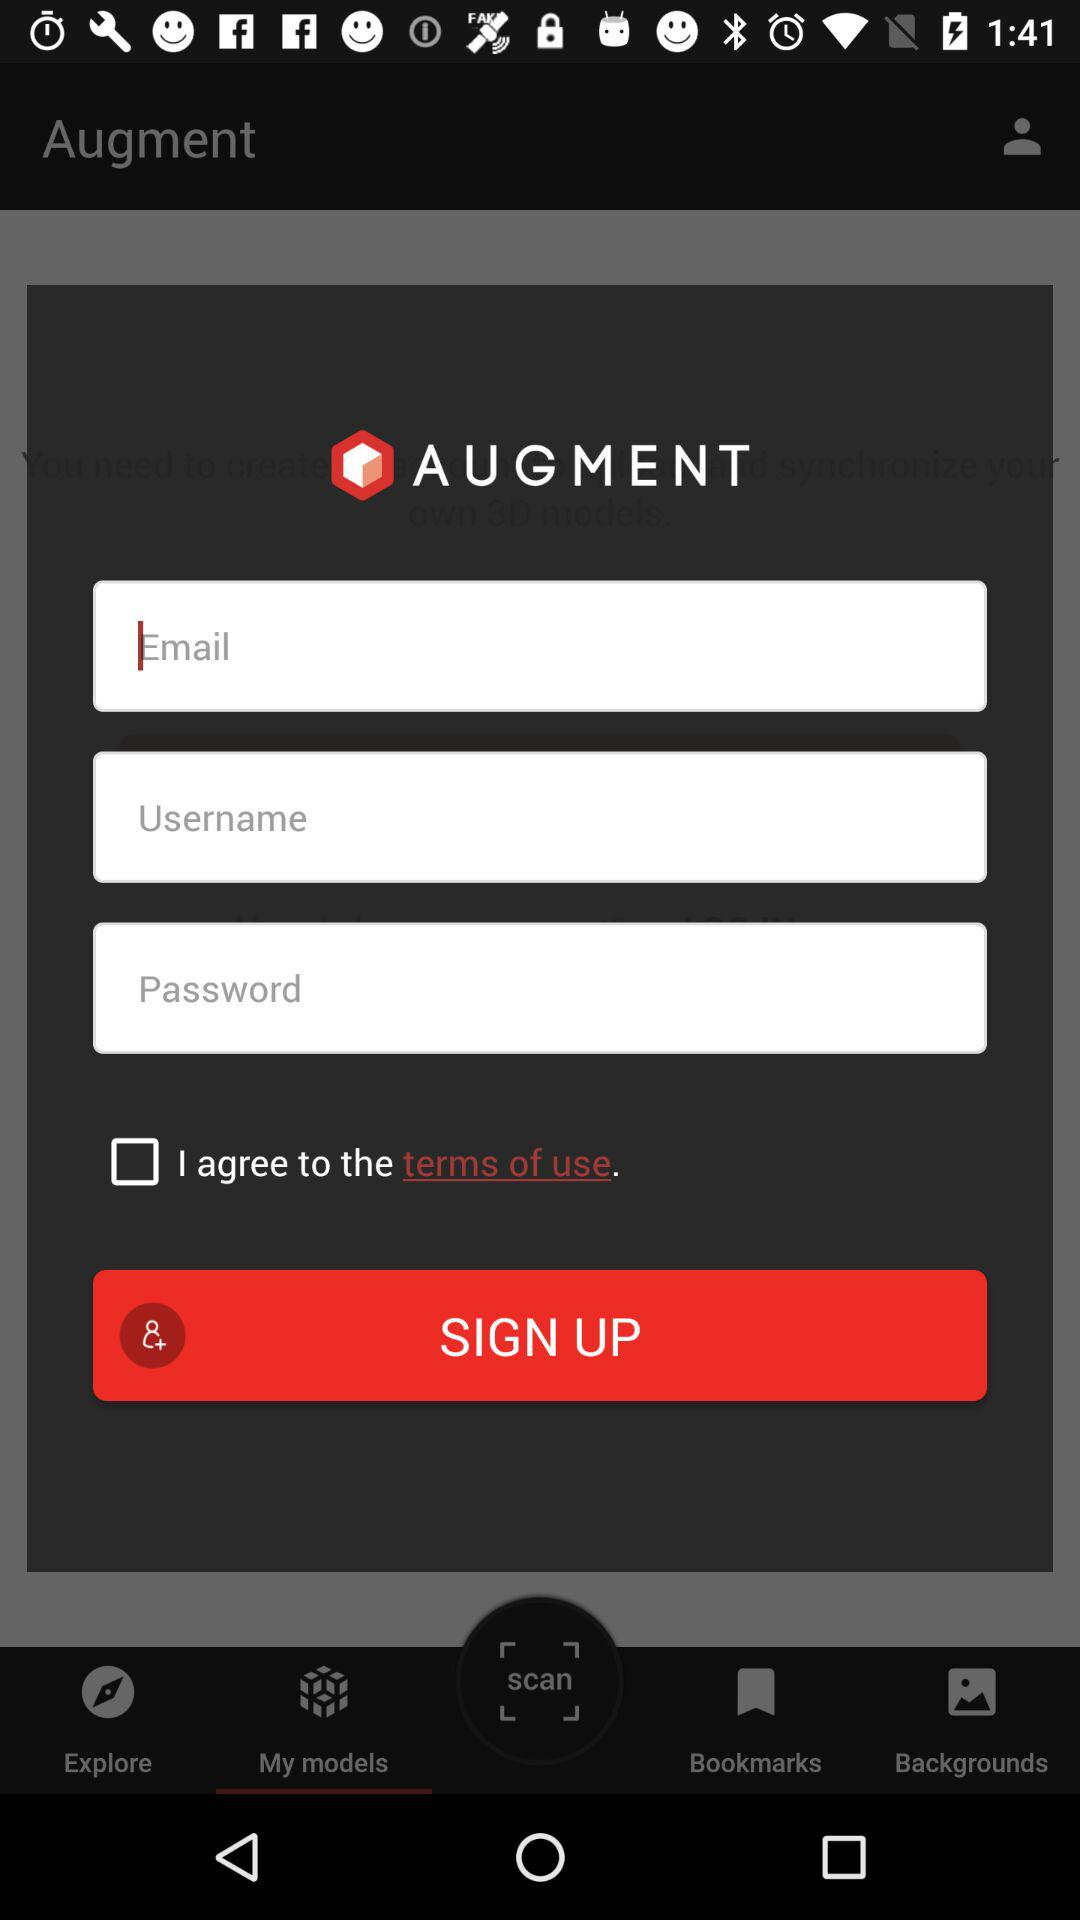Which tab is selected? The selected tab is "My models". 